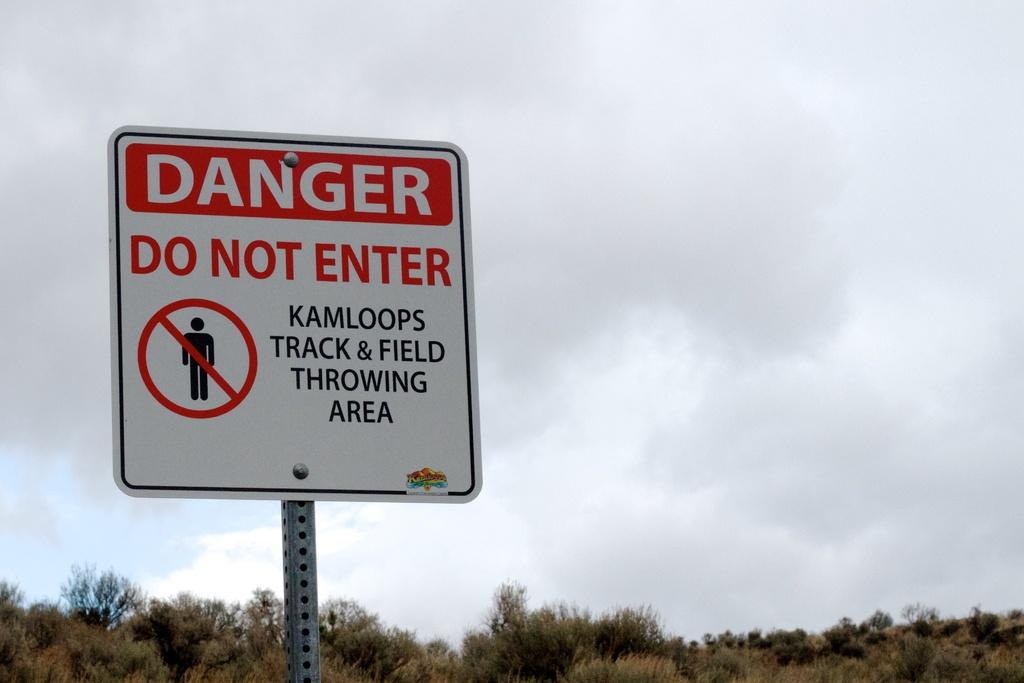<image>
Present a compact description of the photo's key features. A track and field throwing area is located in Kamloops. 